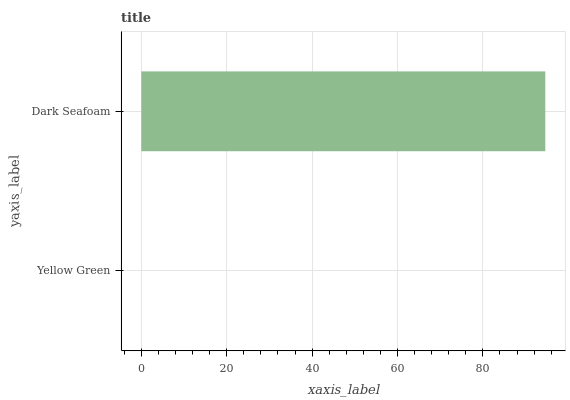Is Yellow Green the minimum?
Answer yes or no. Yes. Is Dark Seafoam the maximum?
Answer yes or no. Yes. Is Dark Seafoam the minimum?
Answer yes or no. No. Is Dark Seafoam greater than Yellow Green?
Answer yes or no. Yes. Is Yellow Green less than Dark Seafoam?
Answer yes or no. Yes. Is Yellow Green greater than Dark Seafoam?
Answer yes or no. No. Is Dark Seafoam less than Yellow Green?
Answer yes or no. No. Is Dark Seafoam the high median?
Answer yes or no. Yes. Is Yellow Green the low median?
Answer yes or no. Yes. Is Yellow Green the high median?
Answer yes or no. No. Is Dark Seafoam the low median?
Answer yes or no. No. 